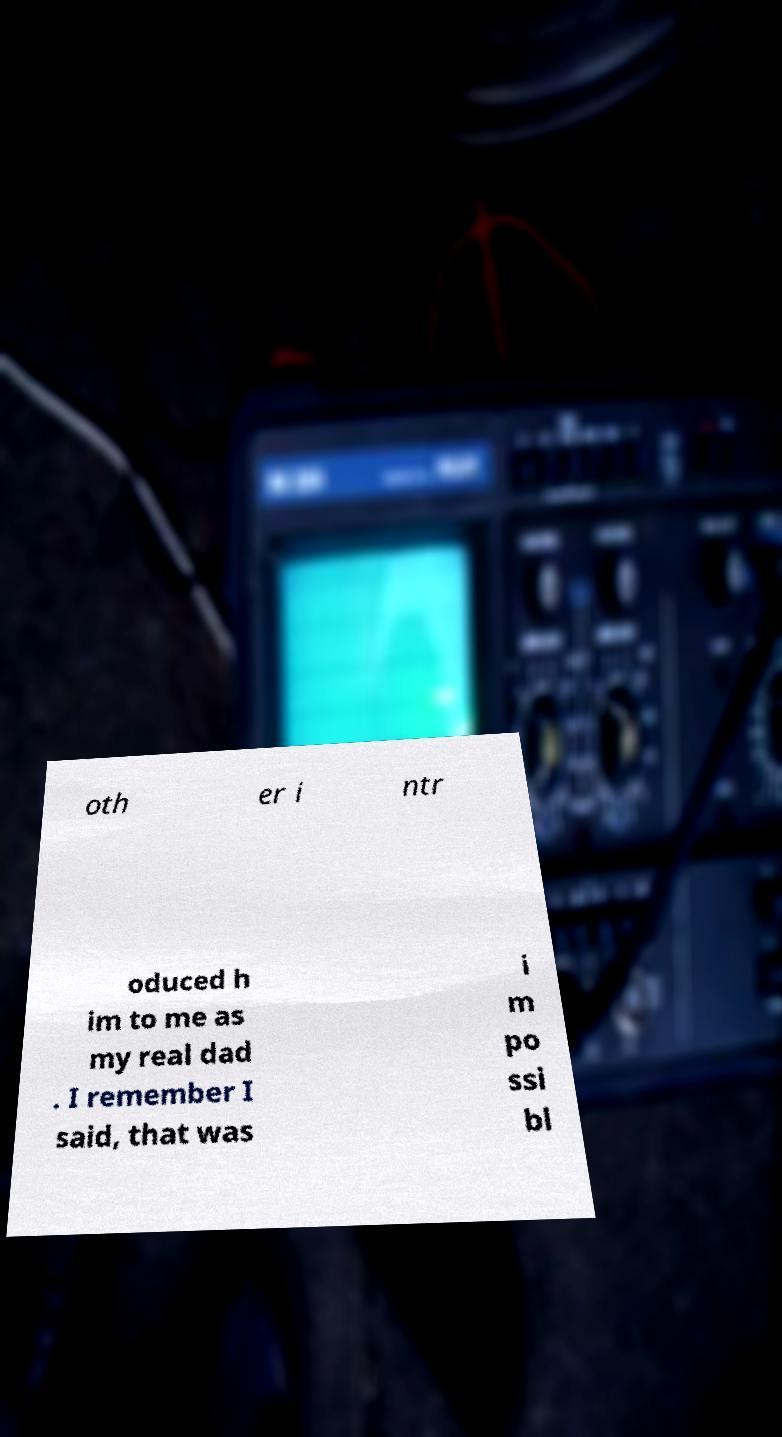Could you assist in decoding the text presented in this image and type it out clearly? oth er i ntr oduced h im to me as my real dad . I remember I said, that was i m po ssi bl 